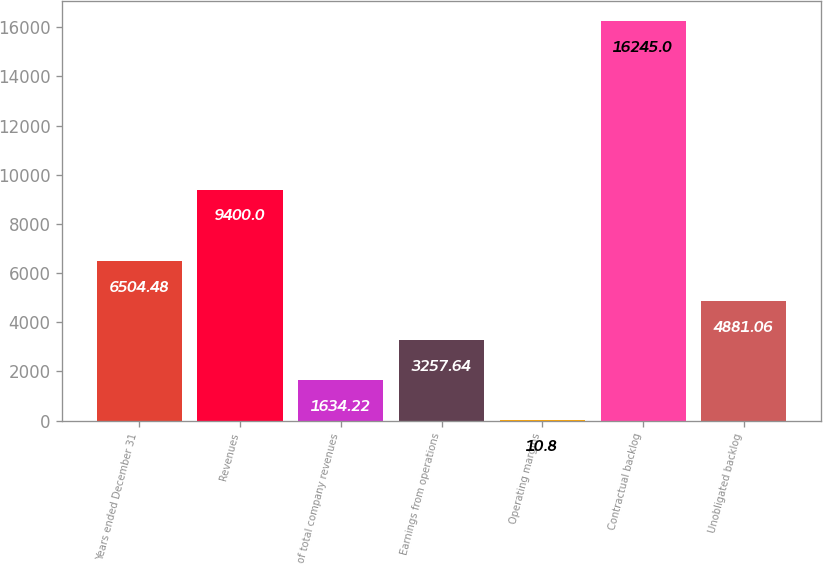Convert chart. <chart><loc_0><loc_0><loc_500><loc_500><bar_chart><fcel>Years ended December 31<fcel>Revenues<fcel>of total company revenues<fcel>Earnings from operations<fcel>Operating margins<fcel>Contractual backlog<fcel>Unobligated backlog<nl><fcel>6504.48<fcel>9400<fcel>1634.22<fcel>3257.64<fcel>10.8<fcel>16245<fcel>4881.06<nl></chart> 